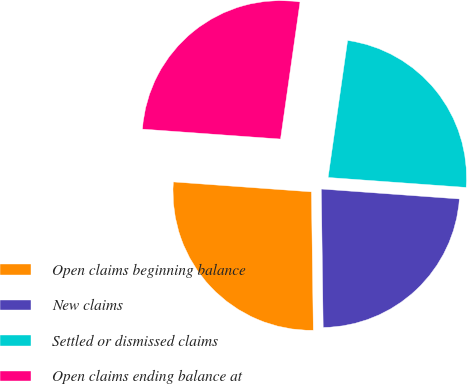<chart> <loc_0><loc_0><loc_500><loc_500><pie_chart><fcel>Open claims beginning balance<fcel>New claims<fcel>Settled or dismissed claims<fcel>Open claims ending balance at<nl><fcel>26.36%<fcel>23.64%<fcel>23.89%<fcel>26.11%<nl></chart> 